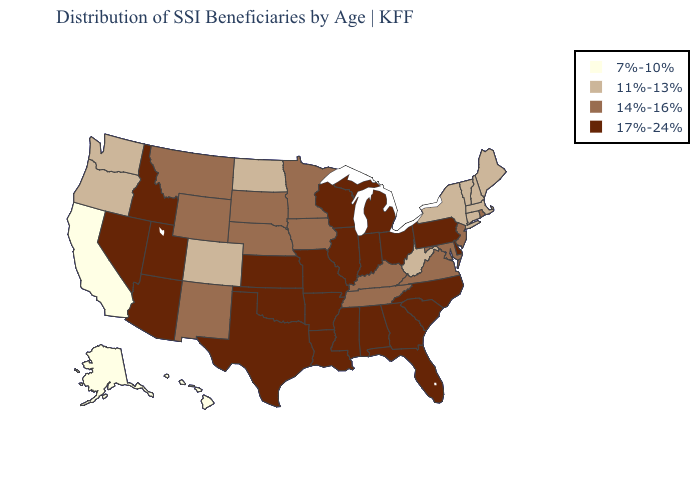Which states have the lowest value in the Northeast?
Quick response, please. Connecticut, Maine, Massachusetts, New Hampshire, New York, Vermont. What is the value of Washington?
Concise answer only. 11%-13%. Does Idaho have the same value as Pennsylvania?
Give a very brief answer. Yes. Does Minnesota have the same value as Virginia?
Short answer required. Yes. Does the first symbol in the legend represent the smallest category?
Be succinct. Yes. Does Pennsylvania have the highest value in the Northeast?
Concise answer only. Yes. What is the value of West Virginia?
Answer briefly. 11%-13%. Is the legend a continuous bar?
Quick response, please. No. Does Louisiana have the highest value in the USA?
Quick response, please. Yes. Among the states that border Ohio , does Indiana have the lowest value?
Keep it brief. No. What is the value of Rhode Island?
Short answer required. 14%-16%. What is the lowest value in the South?
Answer briefly. 11%-13%. Does Montana have the highest value in the USA?
Short answer required. No. 